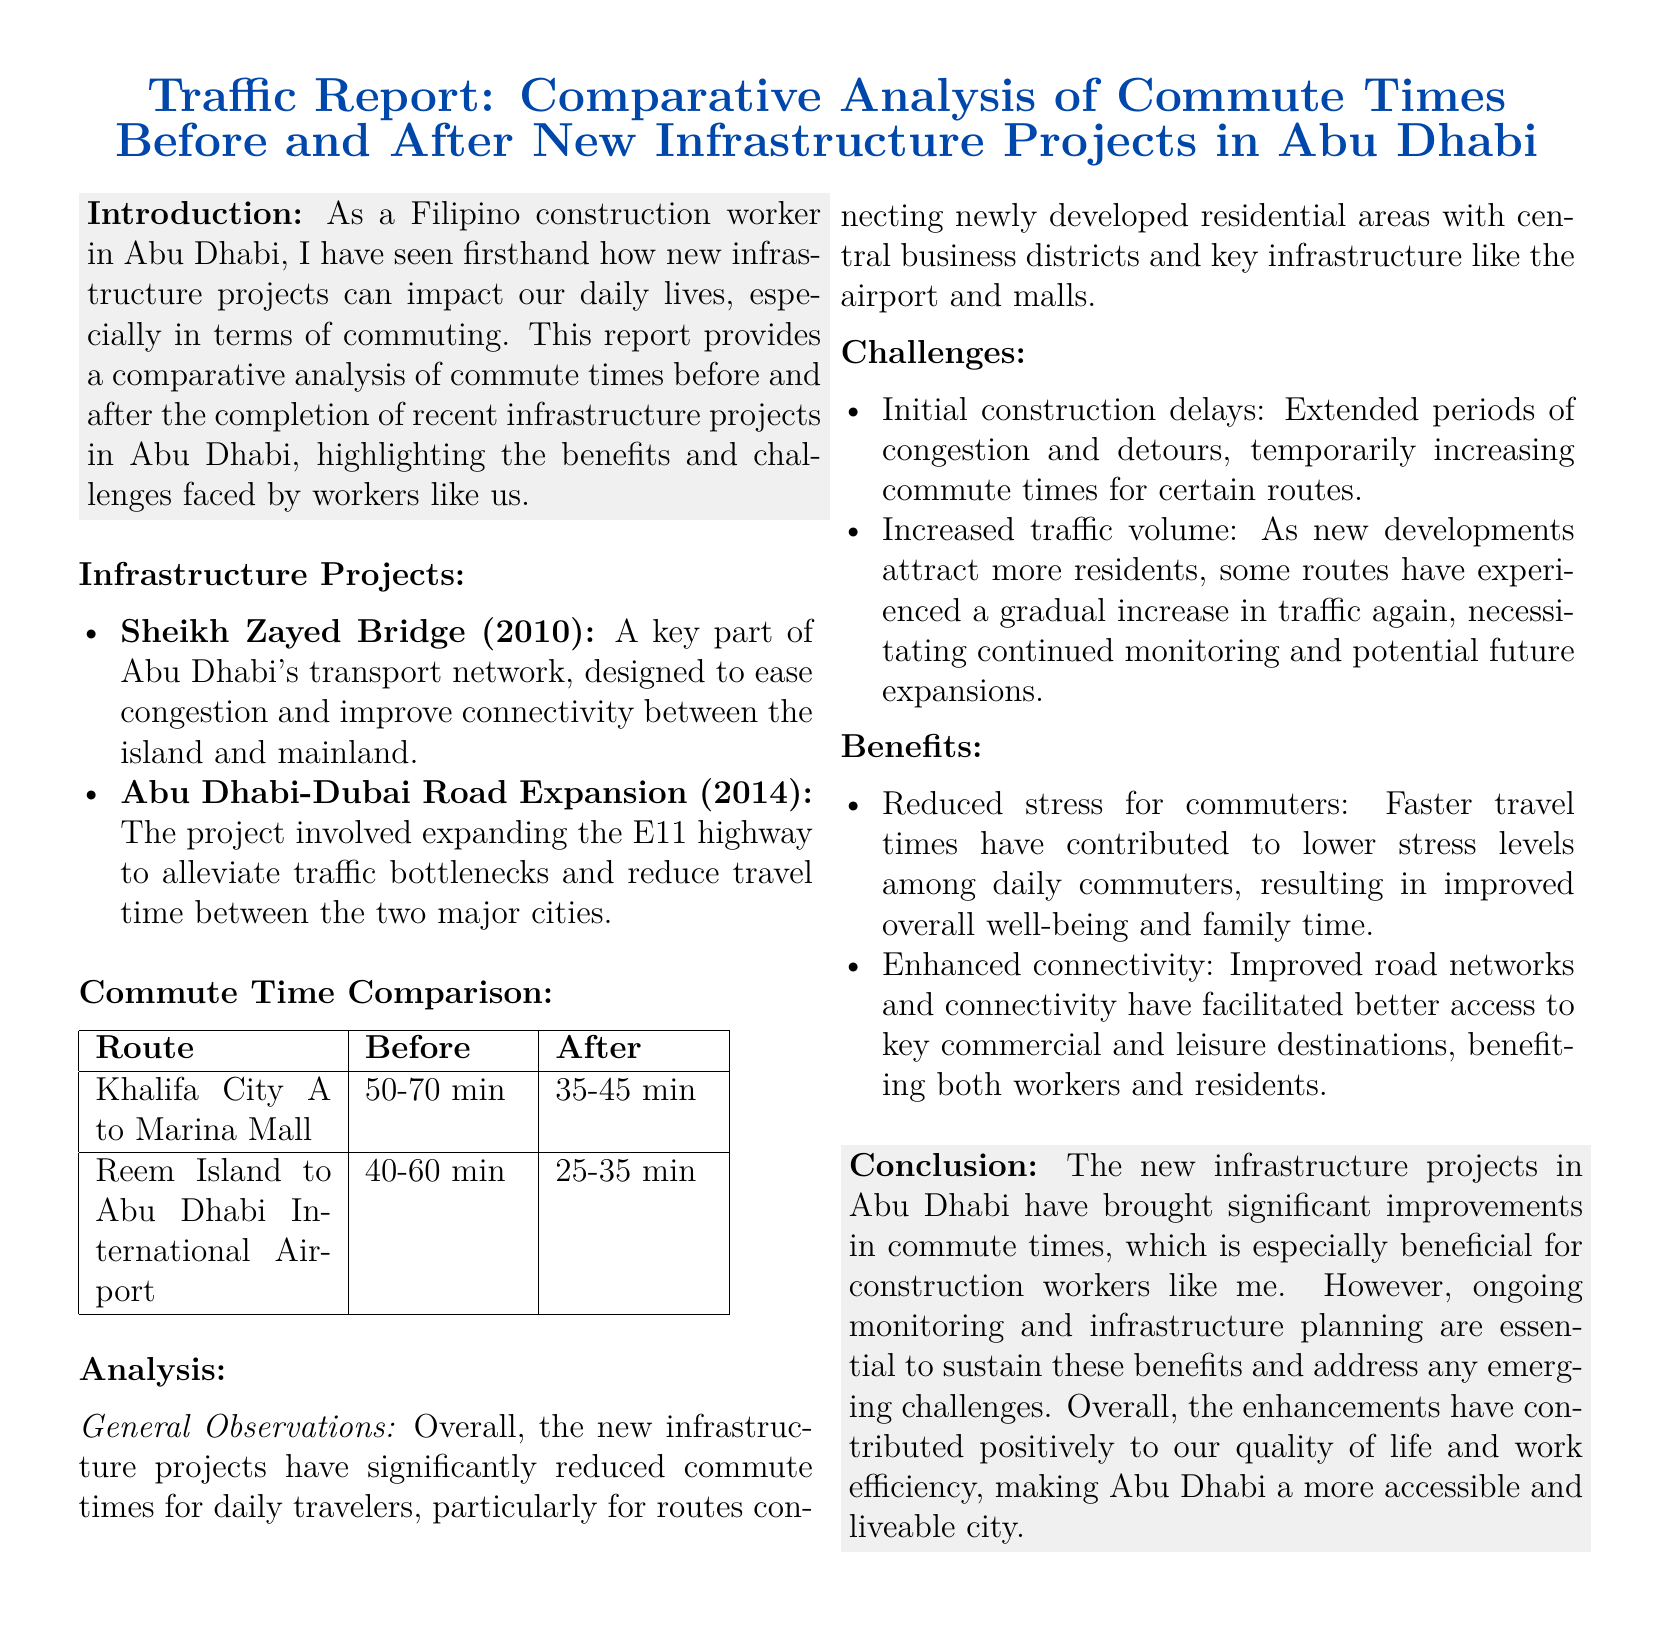What are the two infrastructure projects mentioned? The document lists the Sheikh Zayed Bridge and the Abu Dhabi-Dubai Road Expansion as the two infrastructure projects.
Answer: Sheikh Zayed Bridge, Abu Dhabi-Dubai Road Expansion What was the commute time from Khalifa City A to Marina Mall before the projects? The document provides the before and after commute times for specific routes, stating the before time for this route is 50-70 minutes.
Answer: 50-70 min What is the new commute time from Reem Island to Abu Dhabi International Airport after the projects? The report states the updated commute time from Reem Island to Abu Dhabi International Airport after the projects is 25-35 minutes.
Answer: 25-35 min What benefit does reduced travel time provide for commuters according to the document? The document mentions that reduced travel times have contributed to lower stress levels among daily commuters.
Answer: Lower stress levels What challenge is mentioned regarding increased traffic volume? The document indicates that some routes have experienced a gradual increase in traffic again, necessitating continued monitoring.
Answer: Continued monitoring What year was the Sheikh Zayed Bridge completed? The document states that the Sheikh Zayed Bridge was completed in 2010.
Answer: 2010 What general observation is noted about commute times after the infrastructure projects? The report observes that overall, the new infrastructure projects have significantly reduced commute times for daily travelers.
Answer: Significantly reduced What is emphasized as essential for sustaining the benefits of the new infrastructure? The conclusion of the document emphasizes that ongoing monitoring and infrastructure planning are essential.
Answer: Ongoing monitoring and infrastructure planning What were commuters especially pleased about regarding the new infrastructure? The document highlights that improved access to key commercial and leisure destinations benefitted both workers and residents.
Answer: Improved access to key commercial and leisure destinations 